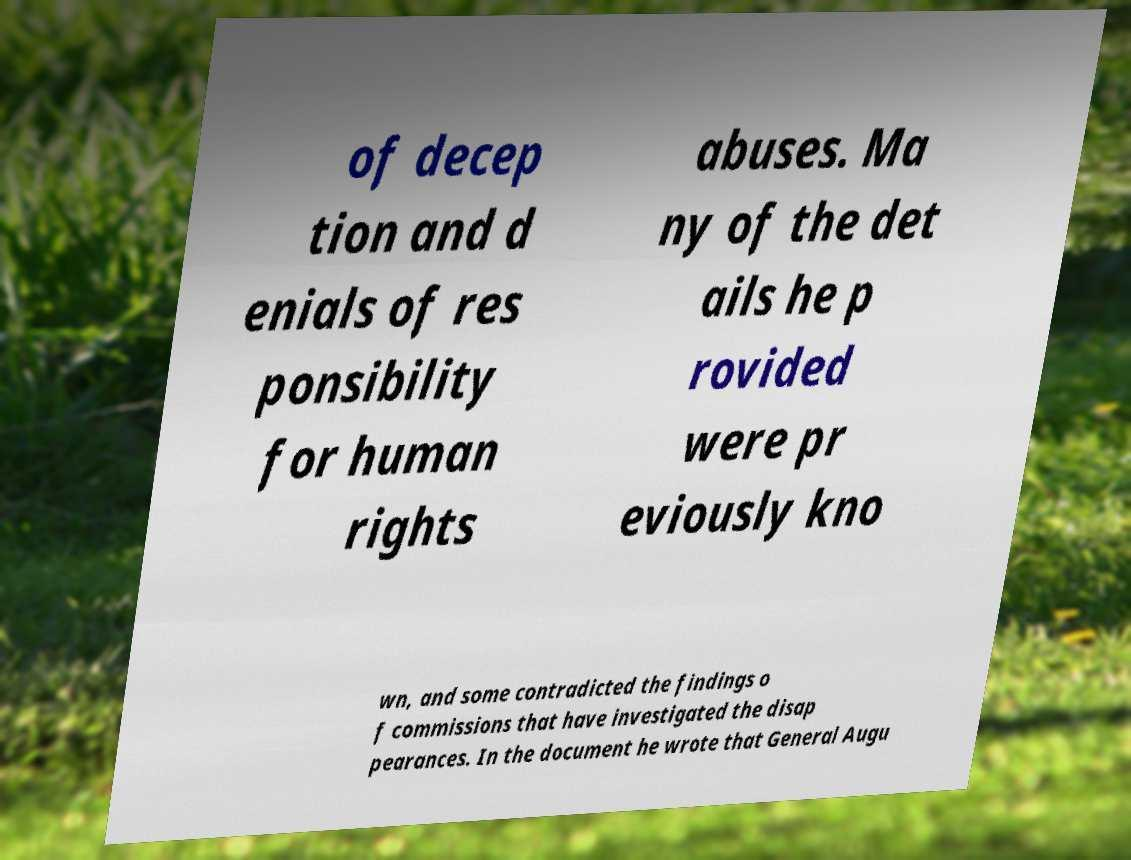Can you read and provide the text displayed in the image?This photo seems to have some interesting text. Can you extract and type it out for me? of decep tion and d enials of res ponsibility for human rights abuses. Ma ny of the det ails he p rovided were pr eviously kno wn, and some contradicted the findings o f commissions that have investigated the disap pearances. In the document he wrote that General Augu 